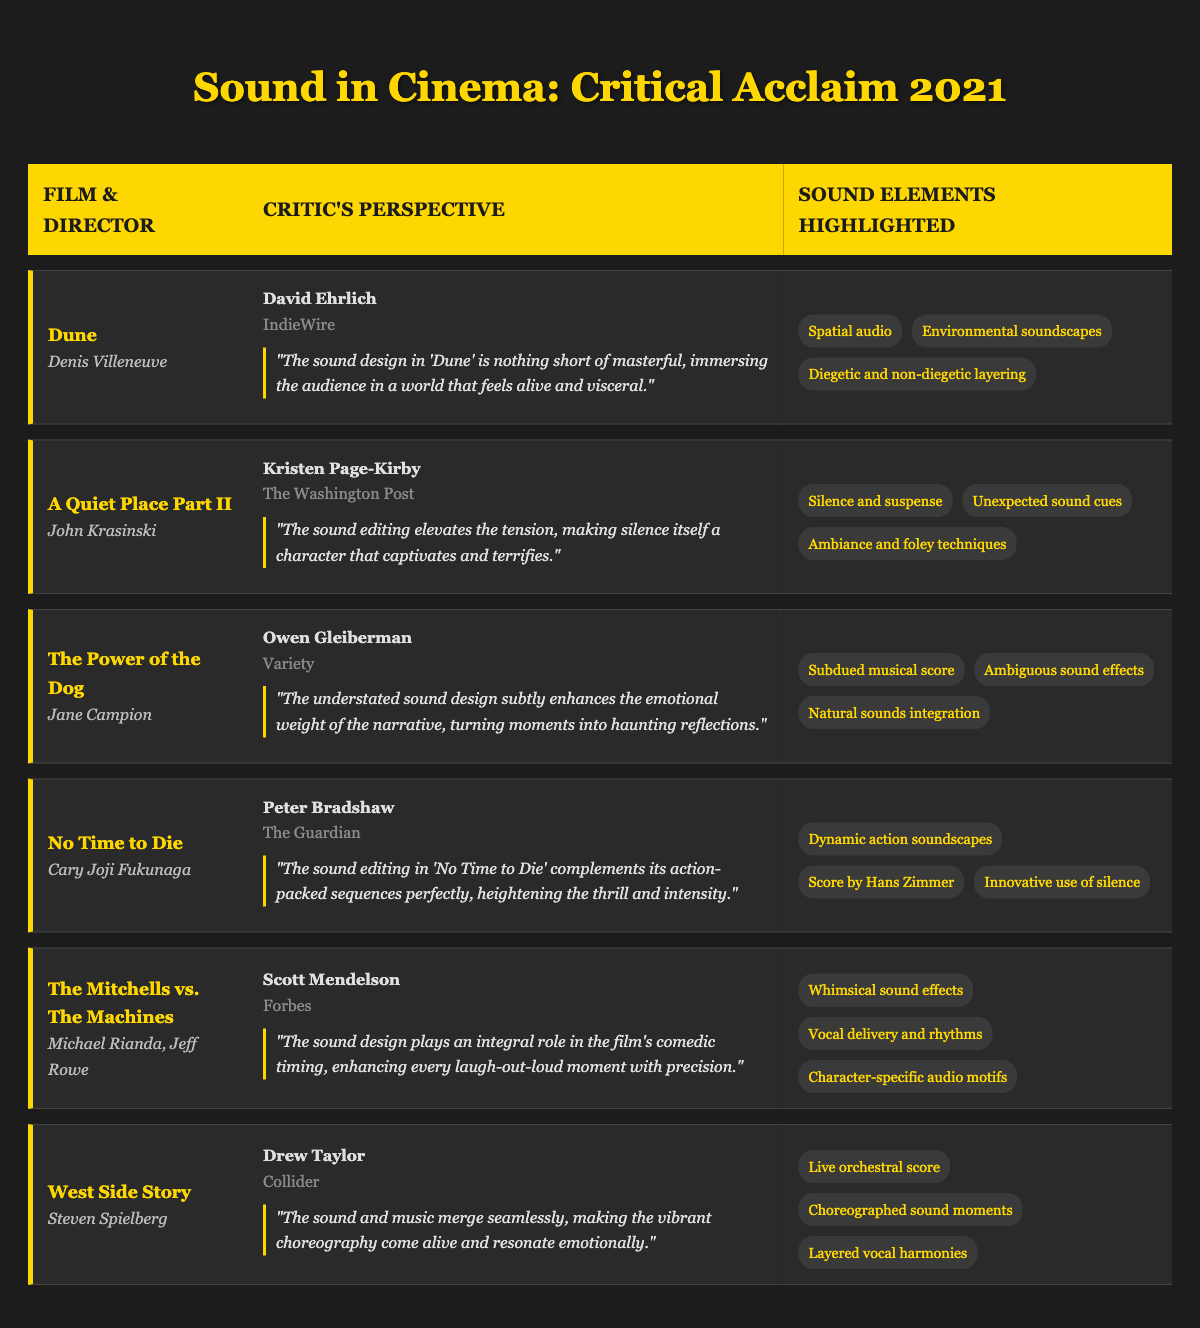What film's sound design is noted for its immersive qualities? The review excerpt for "Dune" mentions that the sound design is masterful and immerses the audience.
Answer: Dune Which film directed by John Krasinski highlights silence as a crucial sound element? "A Quiet Place Part II" is directed by John Krasinski and focuses on silence and suspense, as highlighted in the review excerpt.
Answer: A Quiet Place Part II Is the sound editing in "No Time to Die" described as enhancing the thrill and intensity of action sequences? Yes, the review from The Guardian states that the sound editing in "No Time to Die" perfectly complements its action-packed sequences, heightening thrill and intensity.
Answer: Yes Which film features a subdued musical score as one of its sound elements? "The Power of the Dog" lists subdued musical score among its sound elements in the review provided.
Answer: The Power of the Dog Who wrote the review for "The Mitchells vs. The Machines"? The review for "The Mitchells vs. The Machines" was written by Scott Mendelson according to the table.
Answer: Scott Mendelson How many films feature innovative sound techniques? There are two films that mention innovative sound techniques: "No Time to Die" (with innovative use of silence) and "The Mitchells vs. The Machines" (with whimsical sound effects).
Answer: 2 What is a common theme regarding sound mentioned in the reviewer comments across these films? Many reviews address how sound design enhances emotional engagement or the storytelling aspect in various ways, indicating a strong theme of sound's importance in film.
Answer: Sound enhances emotional engagement Which publication features the review of "West Side Story"? Collider is the publication that features the review for "West Side Story".
Answer: Collider List the sound elements highlighted in "The Power of the Dog". The sound elements highlighted include subdued musical score, ambiguous sound effects, and natural sounds integration.
Answer: Subdued musical score, ambiguous sound effects, natural sounds integration In terms of critical acclaim, which film received mention for its whimsical sound effects? "The Mitchells vs. The Machines" is noted for its whimsical sound effects enhancing comedic timing, as per the review.
Answer: The Mitchells vs. The Machines 